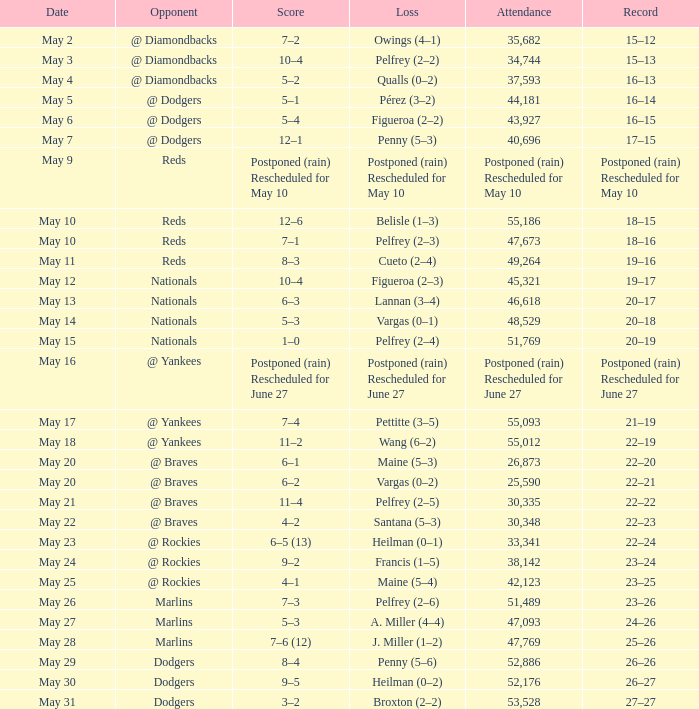Loss of postponed (rain) rescheduled for may 10 had what record? Postponed (rain) Rescheduled for May 10. 